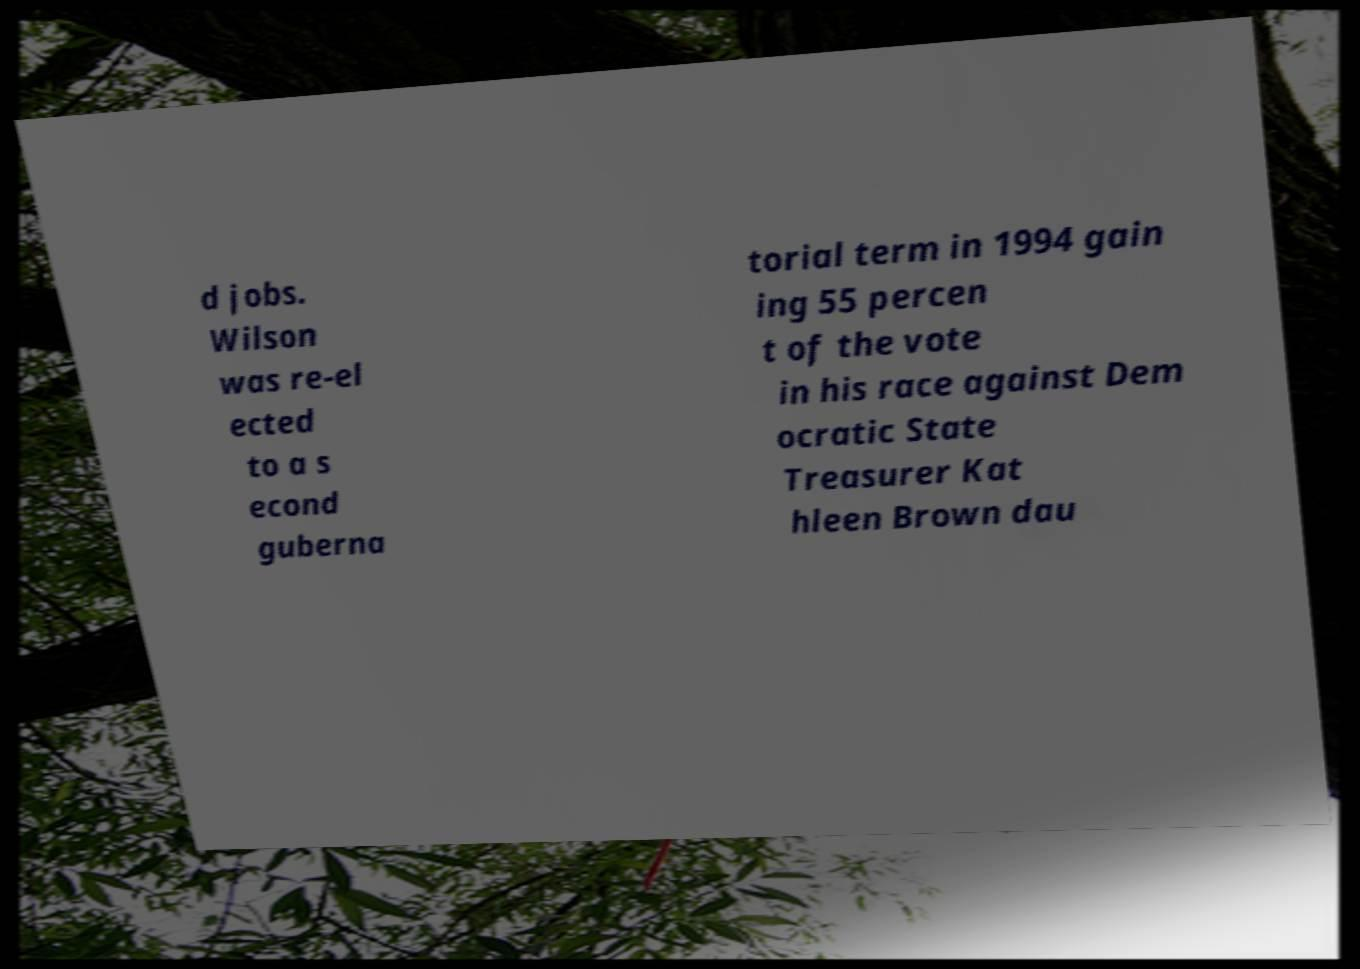What messages or text are displayed in this image? I need them in a readable, typed format. d jobs. Wilson was re-el ected to a s econd guberna torial term in 1994 gain ing 55 percen t of the vote in his race against Dem ocratic State Treasurer Kat hleen Brown dau 